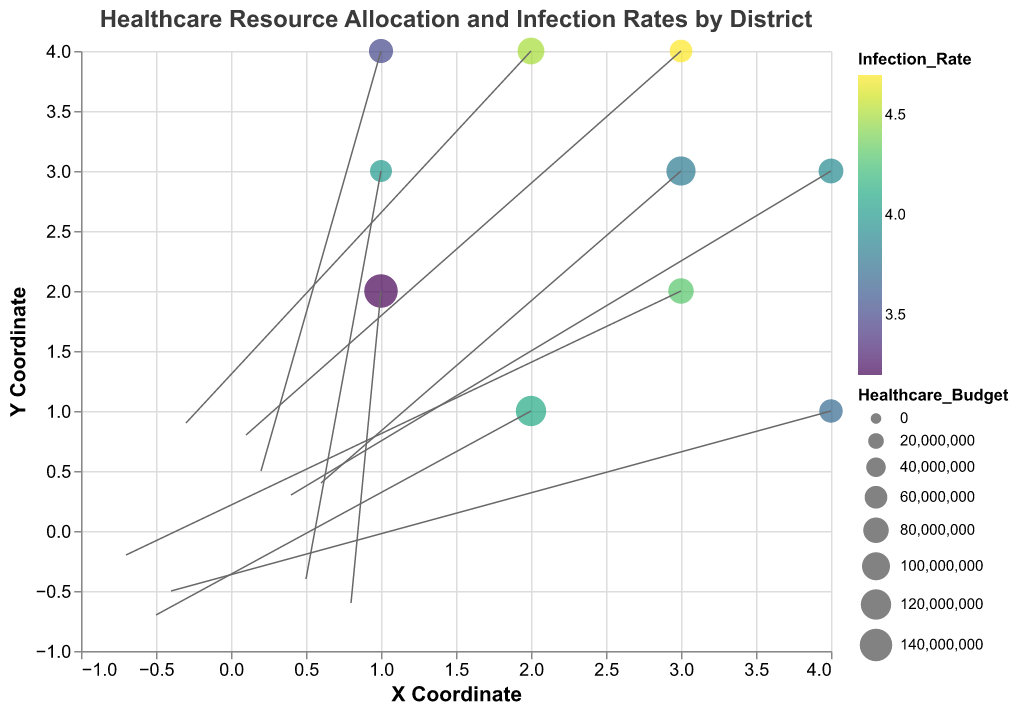How are districts represented in the quiver plot? The districts are represented by points on a coordinate system, with the X and Y coordinates indicating their locations. The size of the points is indicative of the healthcare budget, and the color represents the infection rate.
Answer: Points with varying sizes and colors on the coordinate system Which district has the highest healthcare budget? The sizes of the points represent the healthcare budgets, with larger points indicating larger budgets. Manhattan has the largest point, indicating the highest healthcare budget of 150 million.
Answer: Manhattan How is the infection rate depicted in the plot? The infection rate is shown using the color of the points. Points with higher infection rates appear in colors corresponding to a higher value on the color scale (viridis).
Answer: By the color of the points Which district has the highest infection rate, and how much is it? We find the point with the color corresponding to the highest value on the color scale. Jamaica has the highest infection rate, which is 4.7.
Answer: Jamaica, 4.7 Compare the healthcare budget and infection rate between Queens and Harlem. Queens has a healthcare budget of 110 million and an infection rate of 3.8, while Harlem has a healthcare budget of 80 million and an infection rate of 4.3.
Answer: Queens: $110M, 3.8; Harlem: $80M, 4.3 Which district has the most significant positive allocation in the Y direction? By looking at the length and direction of the arrows (vectors) representing resource allocation, Bronx has the longest upward-directed arrow, indicating the most significant positive allocation in the Y direction (0.9).
Answer: Bronx What is the general trend between healthcare budget and infection rates based on the figure? Generally, districts with lower healthcare budgets tend to have higher infection rates (e.g., Williamsburg, Jamaica), while districts with higher budgets have lower infection rates (e.g., Manhattan, Queens).
Answer: Higher budgets correlate with lower infection rates Identify a district with a notable negative allocation in both X and Y directions. Brooklyn shows a significant negative allocation in both the X and Y directions, indicated by its arrow pointing left and downwards (-0.5, -0.7).
Answer: Brooklyn Which district has the lowest healthcare budget and what is its infection rate? Williamsburg has the smallest point, indicating the lowest healthcare budget of 55 million, with an infection rate of 4.0.
Answer: Williamsburg, 4.0 